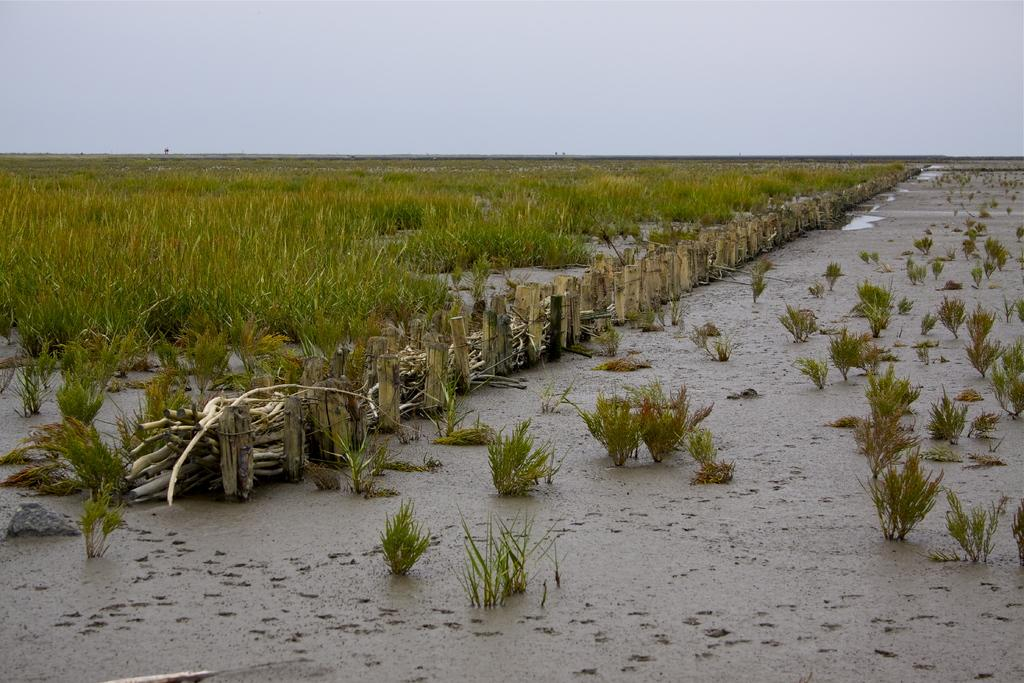What type of vegetation can be seen in the image? There is a crop and grass plants in the image. What structure is present in the image? There is a railing in the image. What can be seen in the background of the image? The sky is visible in the background of the image. Is there a letter addressed to the crop in the image? There is no letter present in the image, and the crop is not a recipient of any mail. Can you see the crop running in the image? The crop is not a living being and cannot run; it is a stationary field of vegetation. 